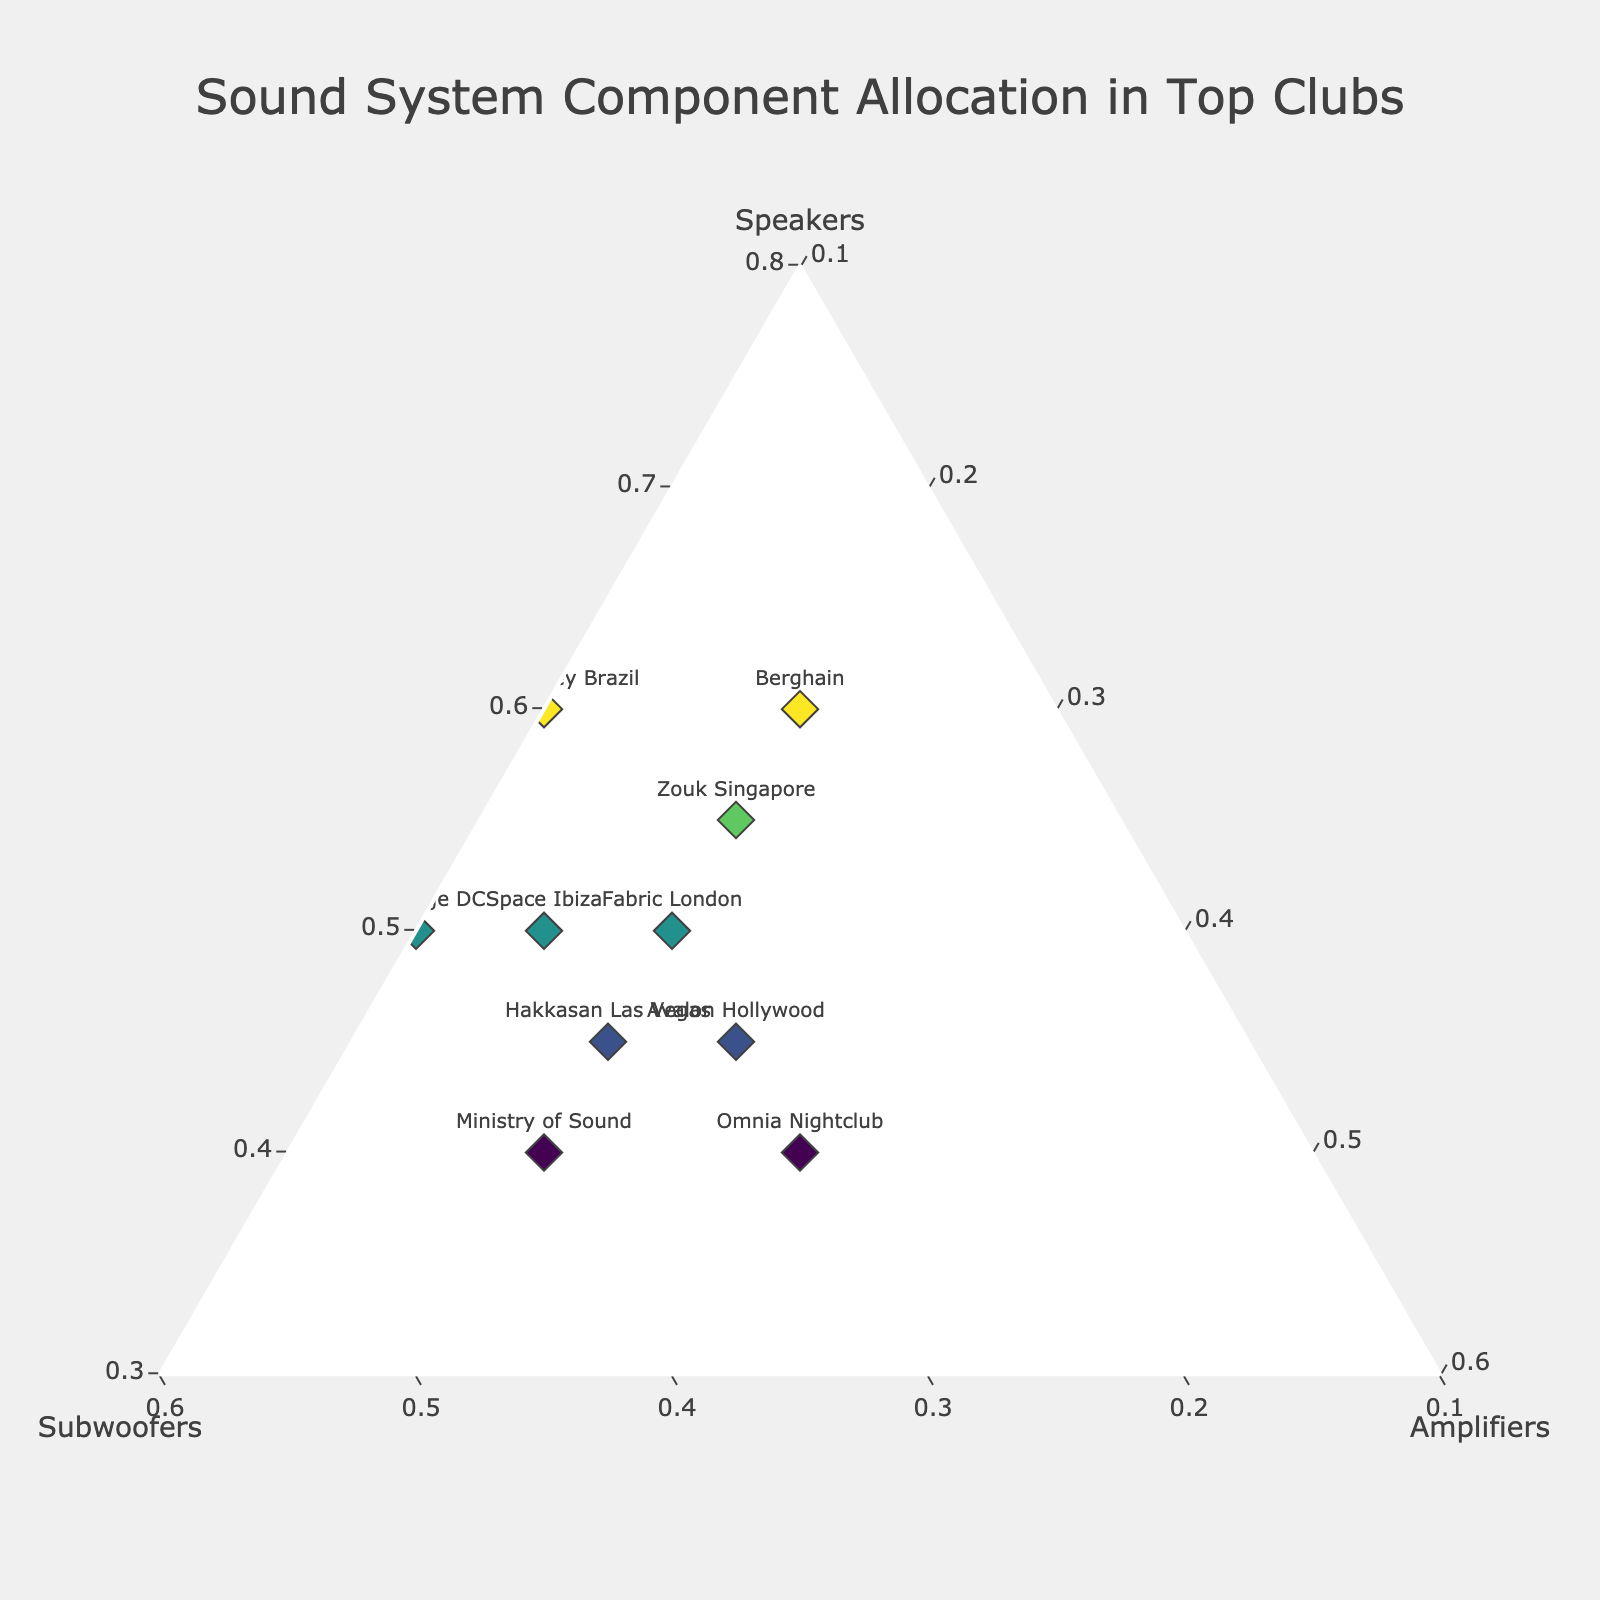What is the title of the plot? The title of the plot is clearly displayed at the top of the figure.
Answer: Sound System Component Allocation in Top Clubs How many clubs are represented in the plot? By counting the number of data points or labels in the plot, you can see that there are 10 clubs represented.
Answer: 10 Which club has the highest allocation of speakers? The club with the highest allocation of speakers is the one with the highest value on the "Speakers" axis. From the data, Green Valley Brazil has 0.6 for speakers, the highest value in the dataset.
Answer: Green Valley Brazil Which clubs have an equal allocation of amplifiers? The clubs with the same value on the "Amplifiers" axis will have equal allocation. Based on the data, the clubs with 0.2 for amplifiers are Fabric London, Ministry of Sound, Berghain, and Hakkasan Las Vegas.
Answer: Fabric London, Ministry of Sound, Berghain, Hakkasan Las Vegas What is the median allocation of subwoofers among the clubs? To find the median, you need to order the values and find the middle one. The values for subwoofers are 0.2, 0.2, 0.25, 0.3, 0.3, 0.3, 0.35, 0.35, 0.4, 0.4. The middle values are 0.3 and 0.3, so the median is (0.3 + 0.3) / 2 = 0.3.
Answer: 0.3 Which club has the most balanced allocation of components? The most balanced allocation would be where the values of speakers, subwoofers, and amplifiers are closest to each other. Omnia Nightclub has allocations of 0.4, 0.3, and 0.3, which are relatively balanced.
Answer: Omnia Nightclub What is the range of the amplifier allocation values? The range is the difference between the maximum and minimum values. The values for amplifiers are 0.1, 0.1, 0.1, 0.15, 0.2, 0.2, 0.2, 0.2, 0.2, 0.25. The range is 0.25 - 0.1 = 0.15.
Answer: 0.15 How does the speaker allocation of Ministry of Sound compare to Avalon Hollywood? Comparing the values, Ministry of Sound has 0.4 for speakers, while Avalon Hollywood has 0.45 for speakers. Thus, Avalon Hollywood has a higher speaker allocation.
Answer: Avalon Hollywood has higher Which club has the lowest allocation of subwoofers, and what is its value? The club with the lowest value on the "Subwoofers" axis is Berghain with 0.2.
Answer: Berghain, 0.2 